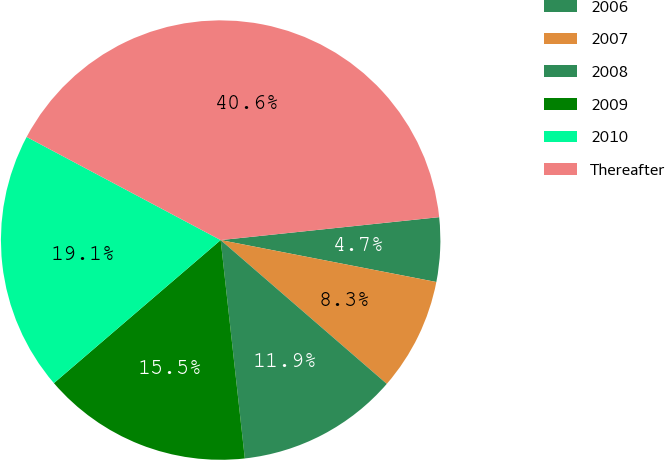<chart> <loc_0><loc_0><loc_500><loc_500><pie_chart><fcel>2006<fcel>2007<fcel>2008<fcel>2009<fcel>2010<fcel>Thereafter<nl><fcel>4.72%<fcel>8.3%<fcel>11.89%<fcel>15.47%<fcel>19.06%<fcel>40.56%<nl></chart> 